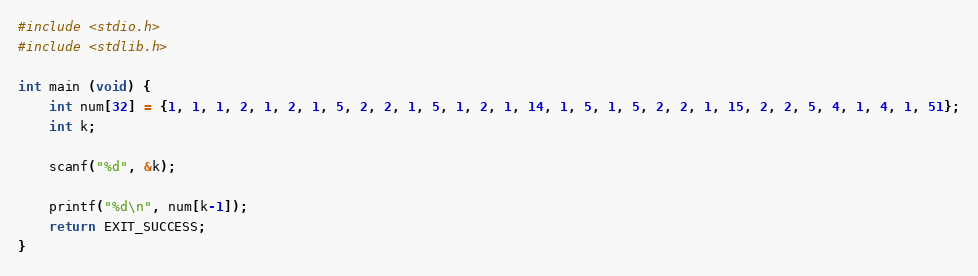<code> <loc_0><loc_0><loc_500><loc_500><_C_>#include <stdio.h>
#include <stdlib.h>

int main (void) {
    int num[32] = {1, 1, 1, 2, 1, 2, 1, 5, 2, 2, 1, 5, 1, 2, 1, 14, 1, 5, 1, 5, 2, 2, 1, 15, 2, 2, 5, 4, 1, 4, 1, 51};
    int k;

    scanf("%d", &k);

    printf("%d\n", num[k-1]);
    return EXIT_SUCCESS;
}
</code> 